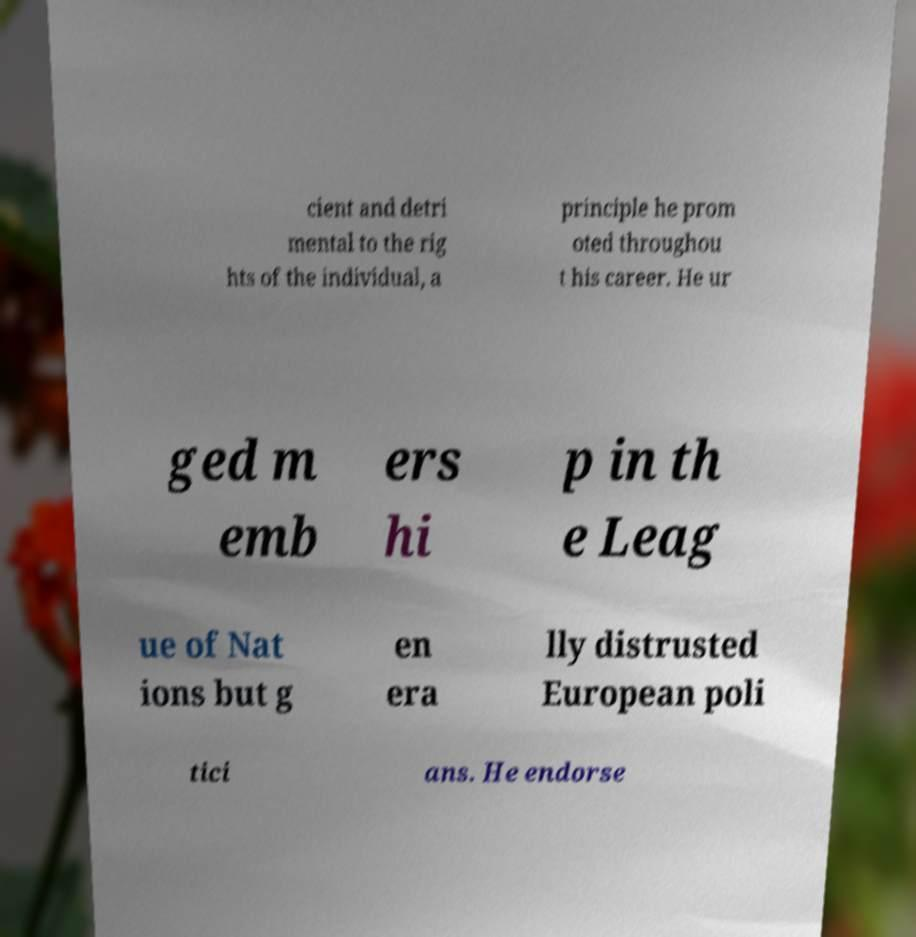Please read and relay the text visible in this image. What does it say? cient and detri mental to the rig hts of the individual, a principle he prom oted throughou t his career. He ur ged m emb ers hi p in th e Leag ue of Nat ions but g en era lly distrusted European poli tici ans. He endorse 